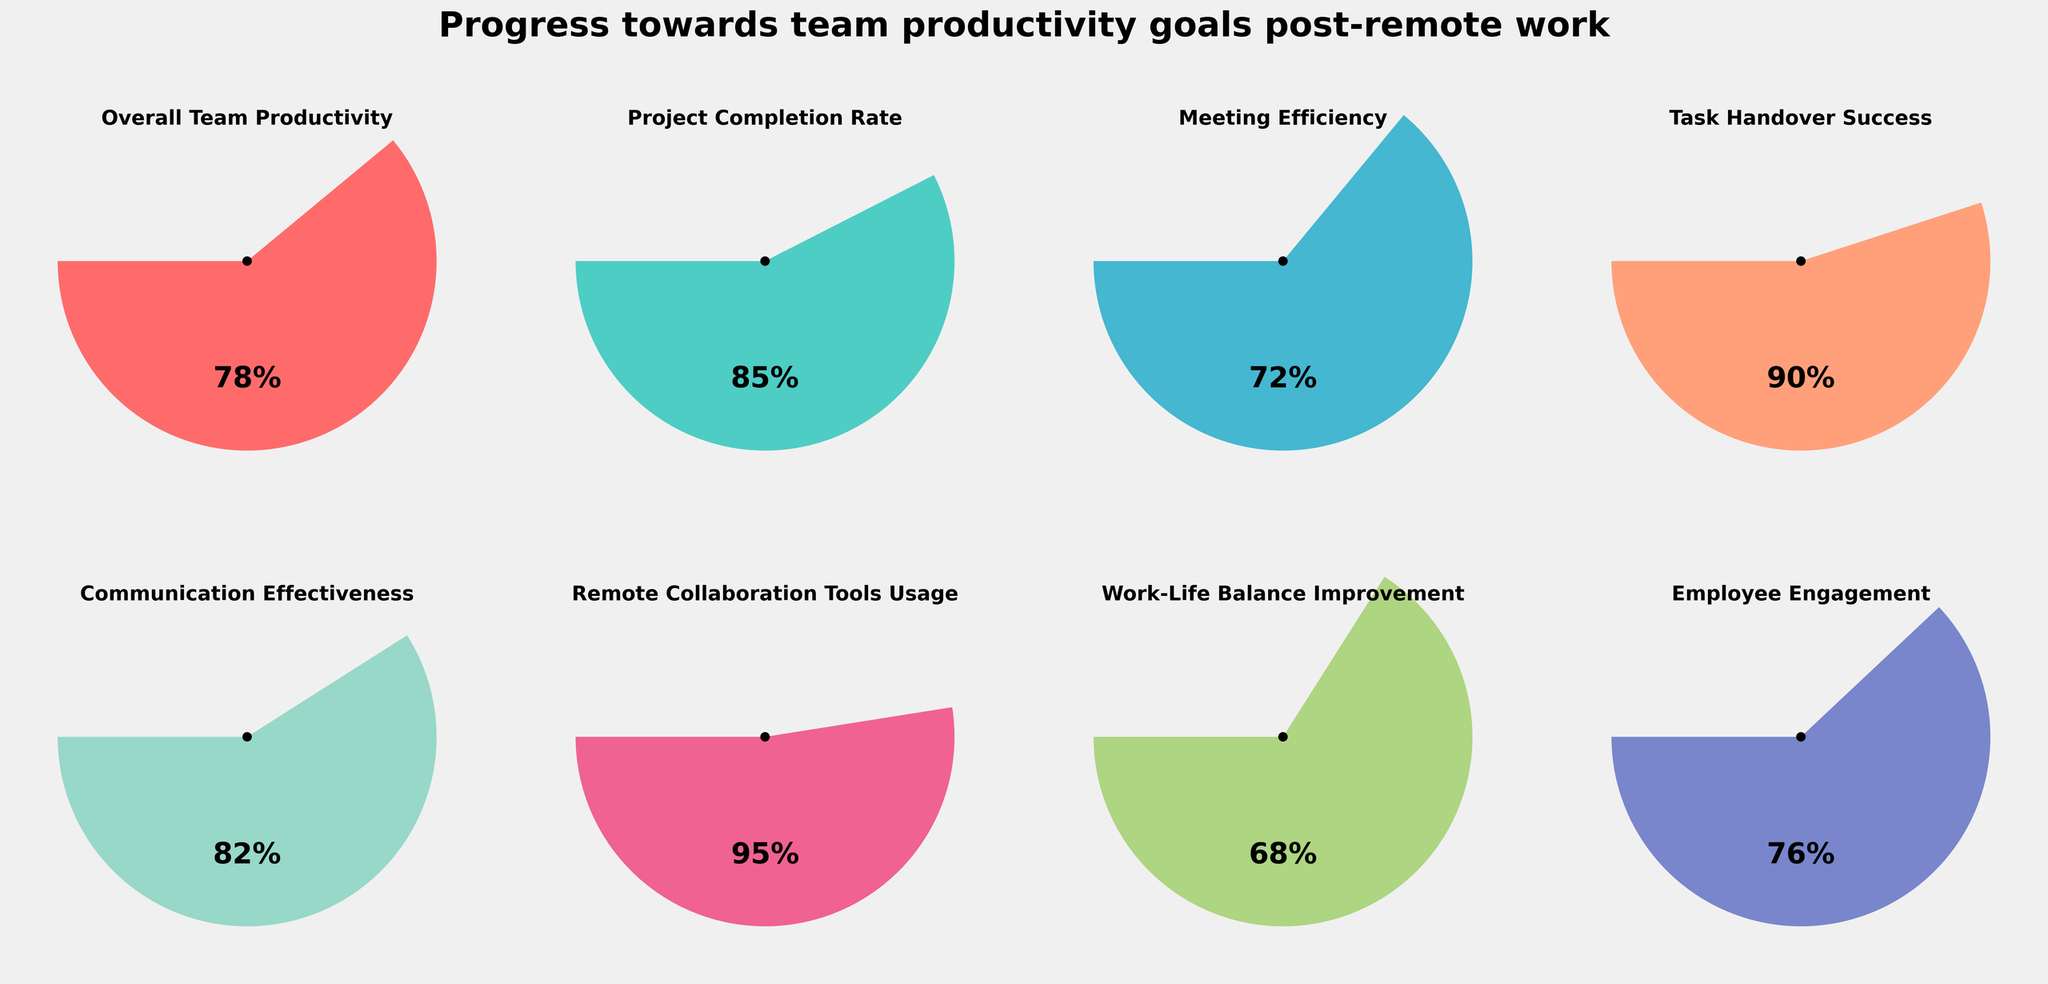what is the progress rate for Meeting Efficiency? The progress rate for Meeting Efficiency can be read directly from the gauge in the plot. It shows the percentage progress towards the goal.
Answer: 72% How does Work-Life Balance Improvement compare to Employee Engagement in terms of progress? Comparing the progress values for Work-Life Balance Improvement and Employee Engagement, we see that Work-Life Balance Improvement is at 68% while Employee Engagement is at 76%. 76% is greater than 68%.
Answer: Employee Engagement is higher What is the average progress for Overall Team Productivity, Project Completion Rate, and Communication Effectiveness? Sum the progress values for Overall Team Productivity (78%), Project Completion Rate (85%), and Communication Effectiveness (82%), and then divide by the number of categories (3): (78 + 85 + 82) / 3 = 245 / 3 = 81.67
Answer: 81.67% Which category has achieved the highest progress towards its goal? The category with the highest progress can be identified by looking for the highest percentage value in the gauges. Remote Collaboration Tools Usage stands out at 95%.
Answer: Remote Collaboration Tools Usage Are there any categories with progress below 70%? If yes, which ones? To find this, check the progress percentages for all categories and identify those below 70%. Work-Life Balance Improvement is at 68%, which is below 70%.
Answer: Work-Life Balance Improvement What is the difference in progress between Task Handover Success and Meeting Efficiency? Subtract the progress percentage of Meeting Efficiency (72%) from Task Handover Success (90%): 90 - 72 = 18
Answer: 18% What is the sum of the progress percentages for Project Completion Rate, Meeting Efficiency, and Remote Collaboration Tools Usage? Adding up the progress rates: Project Completion Rate (85) + Meeting Efficiency (72) + Remote Collaboration Tools Usage (95) results in 85 + 72 + 95 = 252
Answer: 252 How many categories have a progress rate equal to or above 80%? Count the progress rates that are 80% or higher: Project Completion Rate (85%), Communication Effectiveness (82%), Task Handover Success (90%), and Remote Collaboration Tools Usage (95%) makes four categories.
Answer: Four Which category has the lowest progress rate, and what is that rate? Identify the category with the lowest progress rate by comparing all values. Work-Life Balance Improvement at 68% is the lowest.
Answer: Work-Life Balance Improvement at 68% Calculate the mean progress rate across all categories displayed in the gauges. Sum all the progress rates and divide by the number of categories: (78 + 85 + 72 + 90 + 82 + 95 + 68 + 76) / 8 = 646 / 8 = 80.75
Answer: 80.75% 